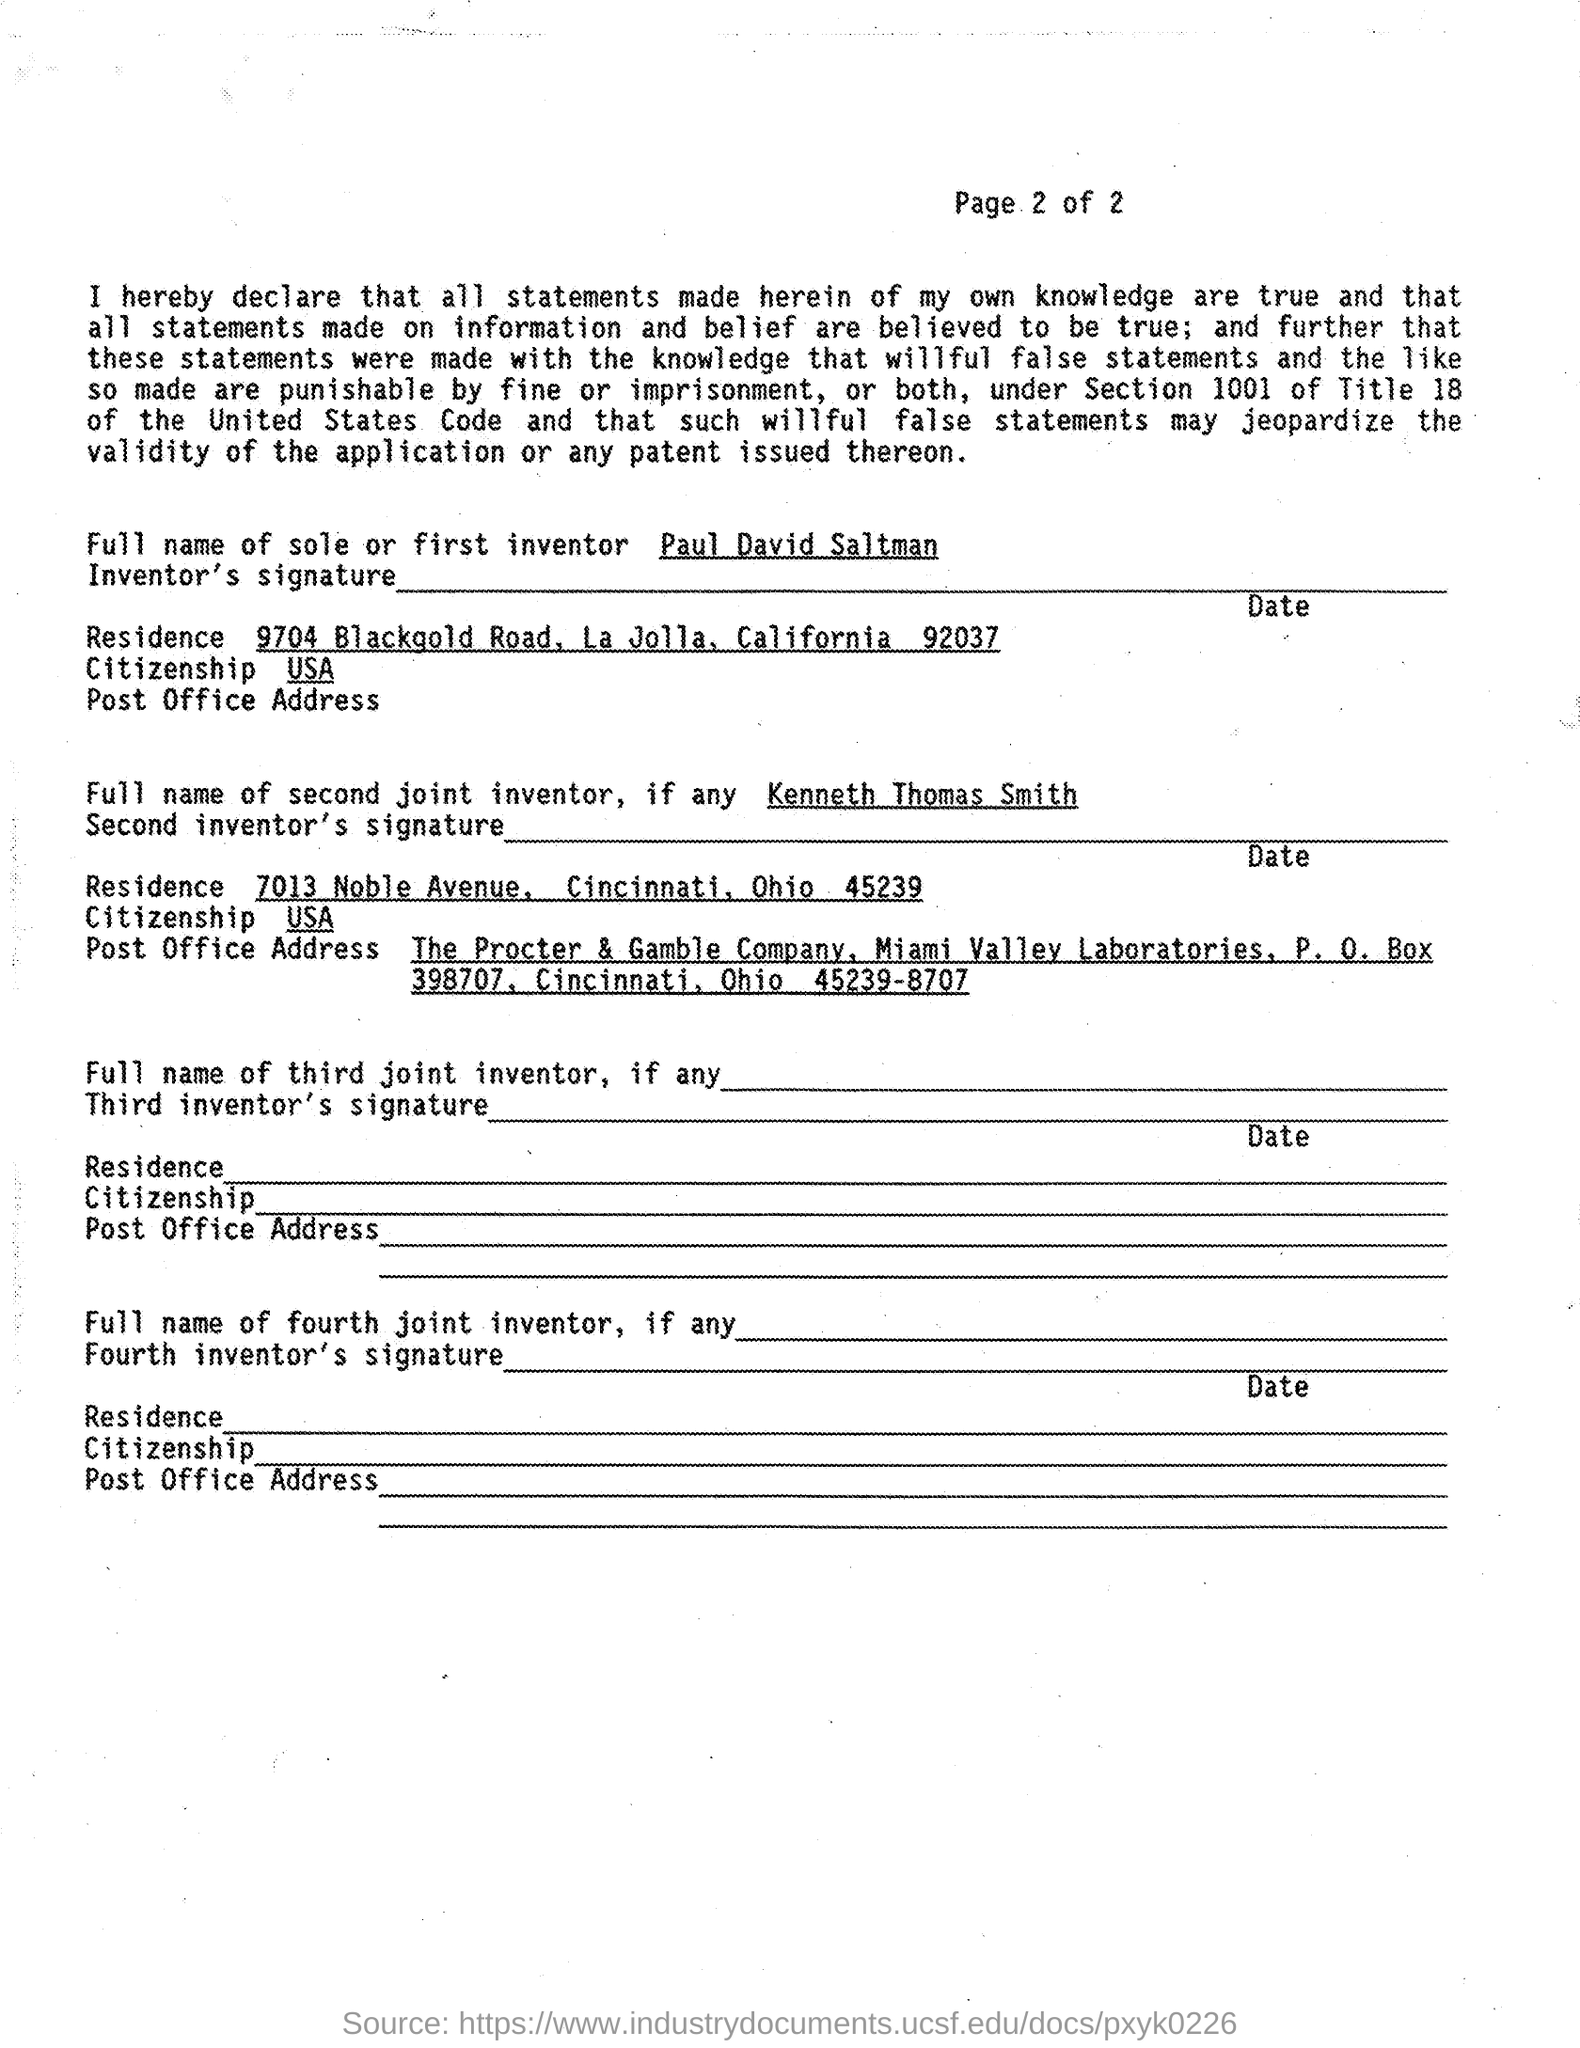Mention a couple of crucial points in this snapshot. The first inventor is Paul David Saltman. 